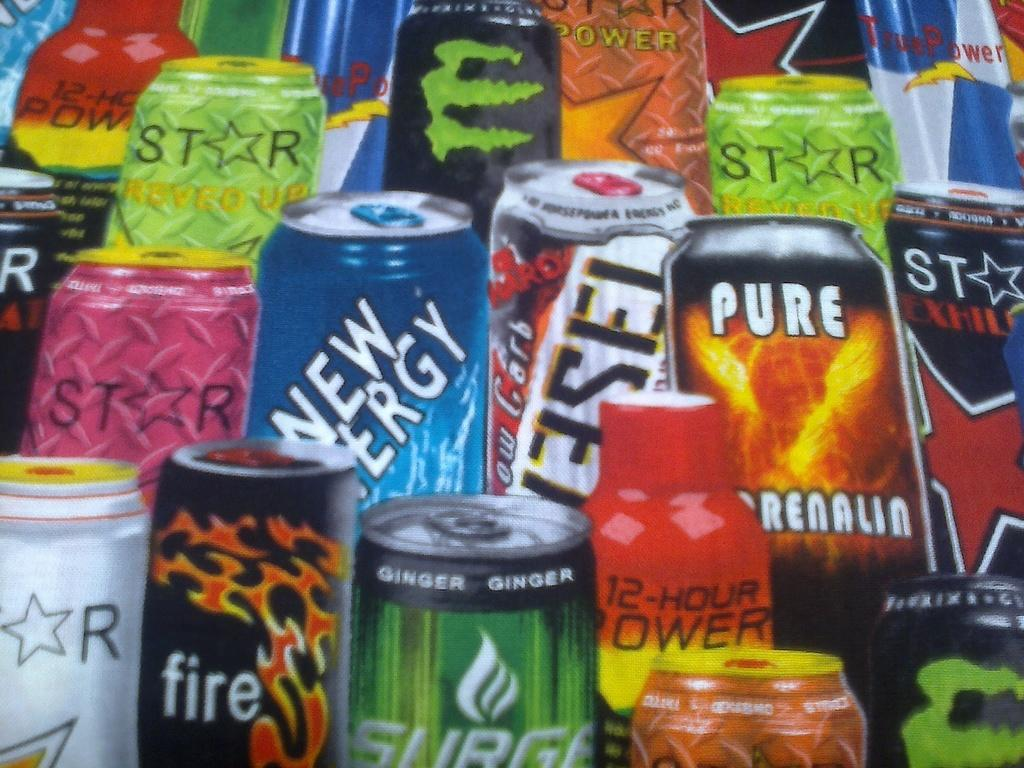<image>
Offer a succinct explanation of the picture presented. A poster shows many different cans of energy drinks, including STAR, FIRE, and PURE. 